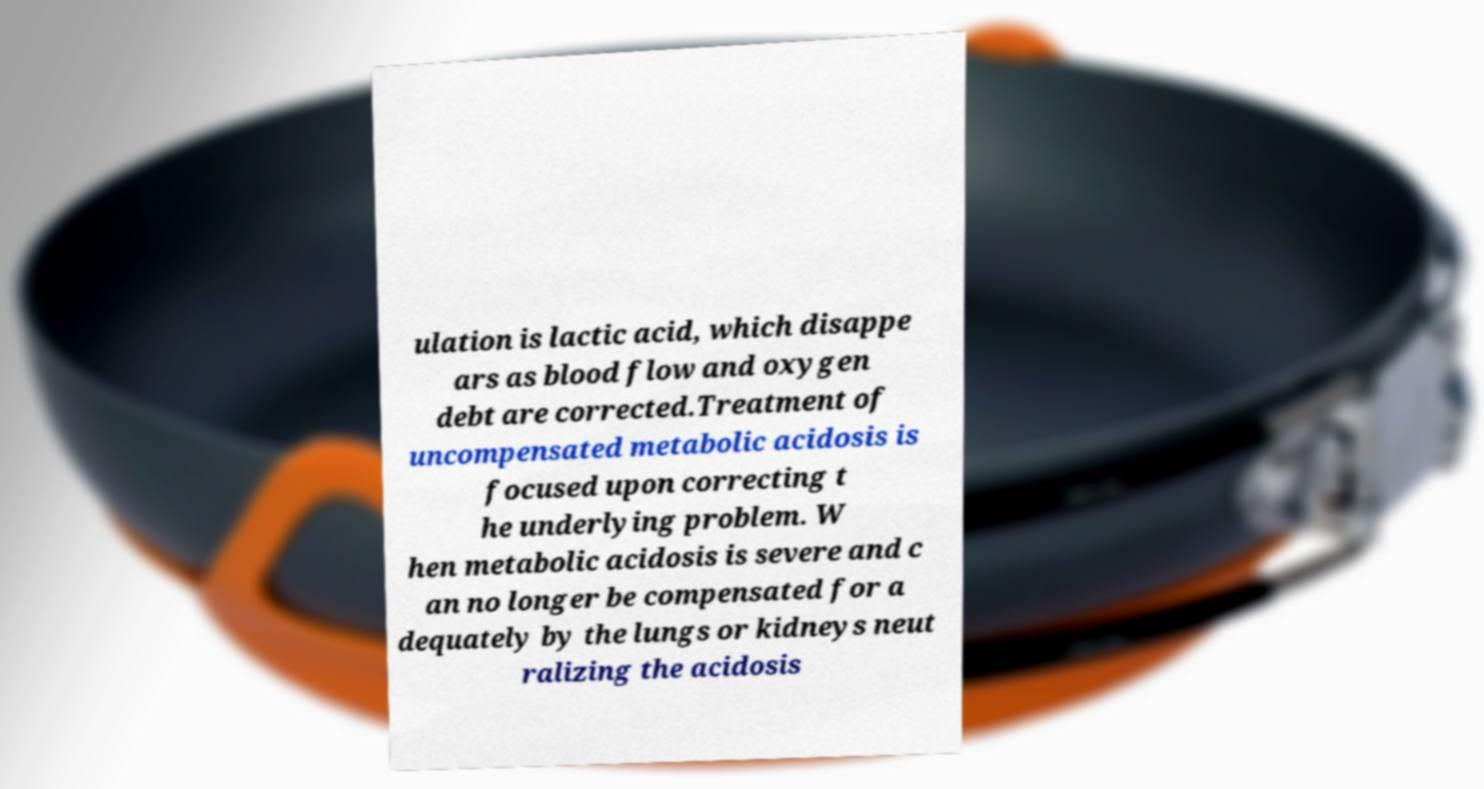I need the written content from this picture converted into text. Can you do that? ulation is lactic acid, which disappe ars as blood flow and oxygen debt are corrected.Treatment of uncompensated metabolic acidosis is focused upon correcting t he underlying problem. W hen metabolic acidosis is severe and c an no longer be compensated for a dequately by the lungs or kidneys neut ralizing the acidosis 